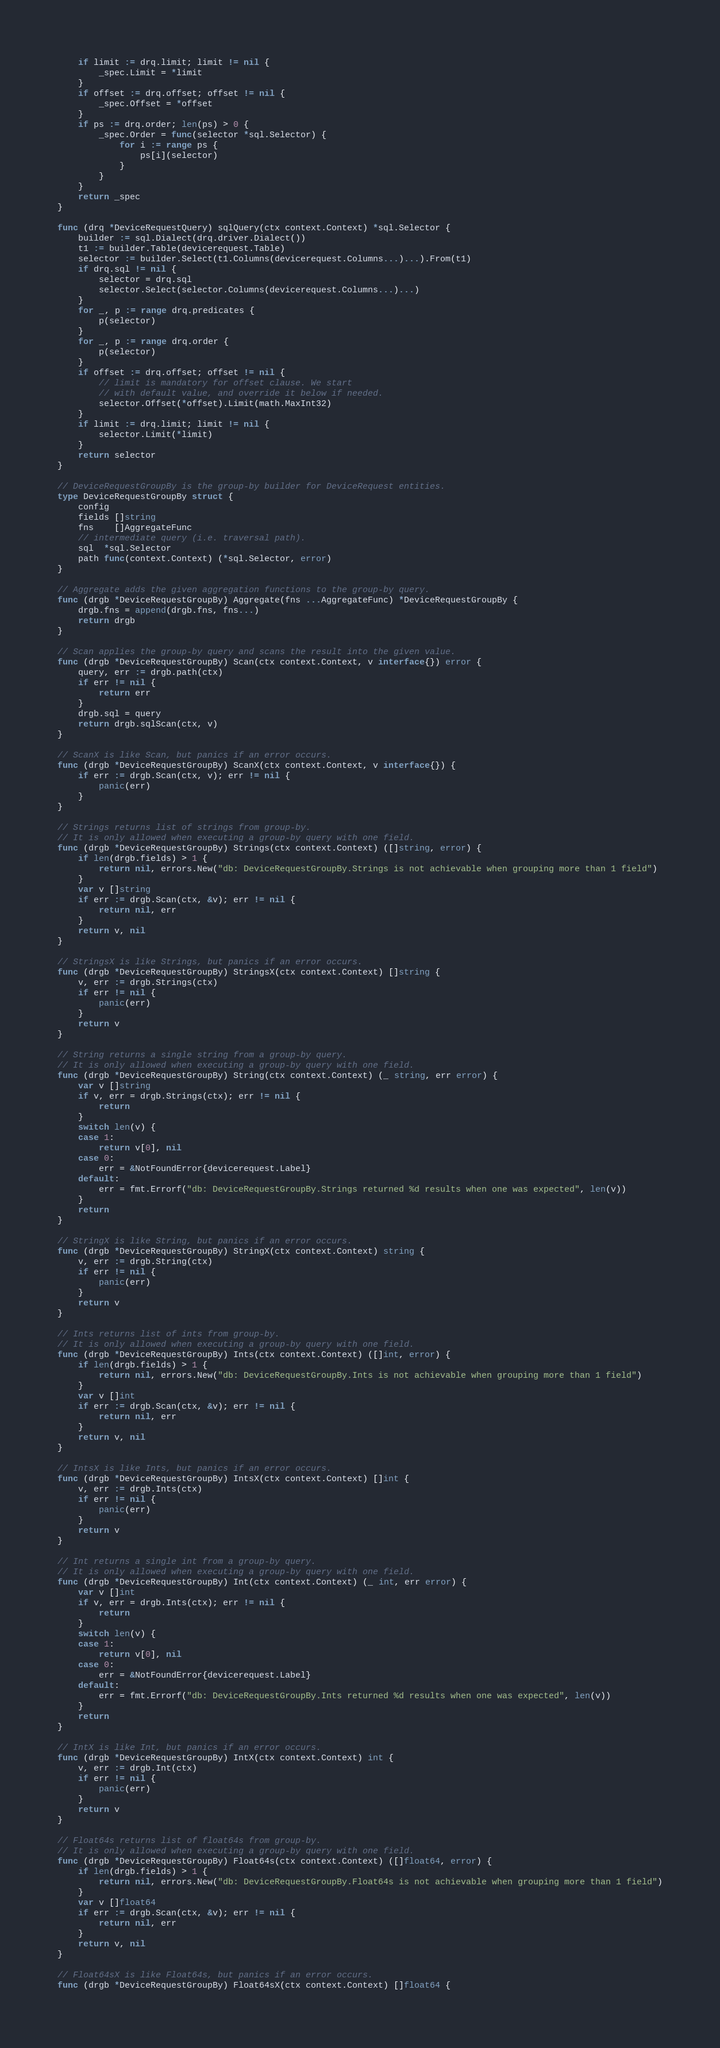Convert code to text. <code><loc_0><loc_0><loc_500><loc_500><_Go_>	if limit := drq.limit; limit != nil {
		_spec.Limit = *limit
	}
	if offset := drq.offset; offset != nil {
		_spec.Offset = *offset
	}
	if ps := drq.order; len(ps) > 0 {
		_spec.Order = func(selector *sql.Selector) {
			for i := range ps {
				ps[i](selector)
			}
		}
	}
	return _spec
}

func (drq *DeviceRequestQuery) sqlQuery(ctx context.Context) *sql.Selector {
	builder := sql.Dialect(drq.driver.Dialect())
	t1 := builder.Table(devicerequest.Table)
	selector := builder.Select(t1.Columns(devicerequest.Columns...)...).From(t1)
	if drq.sql != nil {
		selector = drq.sql
		selector.Select(selector.Columns(devicerequest.Columns...)...)
	}
	for _, p := range drq.predicates {
		p(selector)
	}
	for _, p := range drq.order {
		p(selector)
	}
	if offset := drq.offset; offset != nil {
		// limit is mandatory for offset clause. We start
		// with default value, and override it below if needed.
		selector.Offset(*offset).Limit(math.MaxInt32)
	}
	if limit := drq.limit; limit != nil {
		selector.Limit(*limit)
	}
	return selector
}

// DeviceRequestGroupBy is the group-by builder for DeviceRequest entities.
type DeviceRequestGroupBy struct {
	config
	fields []string
	fns    []AggregateFunc
	// intermediate query (i.e. traversal path).
	sql  *sql.Selector
	path func(context.Context) (*sql.Selector, error)
}

// Aggregate adds the given aggregation functions to the group-by query.
func (drgb *DeviceRequestGroupBy) Aggregate(fns ...AggregateFunc) *DeviceRequestGroupBy {
	drgb.fns = append(drgb.fns, fns...)
	return drgb
}

// Scan applies the group-by query and scans the result into the given value.
func (drgb *DeviceRequestGroupBy) Scan(ctx context.Context, v interface{}) error {
	query, err := drgb.path(ctx)
	if err != nil {
		return err
	}
	drgb.sql = query
	return drgb.sqlScan(ctx, v)
}

// ScanX is like Scan, but panics if an error occurs.
func (drgb *DeviceRequestGroupBy) ScanX(ctx context.Context, v interface{}) {
	if err := drgb.Scan(ctx, v); err != nil {
		panic(err)
	}
}

// Strings returns list of strings from group-by.
// It is only allowed when executing a group-by query with one field.
func (drgb *DeviceRequestGroupBy) Strings(ctx context.Context) ([]string, error) {
	if len(drgb.fields) > 1 {
		return nil, errors.New("db: DeviceRequestGroupBy.Strings is not achievable when grouping more than 1 field")
	}
	var v []string
	if err := drgb.Scan(ctx, &v); err != nil {
		return nil, err
	}
	return v, nil
}

// StringsX is like Strings, but panics if an error occurs.
func (drgb *DeviceRequestGroupBy) StringsX(ctx context.Context) []string {
	v, err := drgb.Strings(ctx)
	if err != nil {
		panic(err)
	}
	return v
}

// String returns a single string from a group-by query.
// It is only allowed when executing a group-by query with one field.
func (drgb *DeviceRequestGroupBy) String(ctx context.Context) (_ string, err error) {
	var v []string
	if v, err = drgb.Strings(ctx); err != nil {
		return
	}
	switch len(v) {
	case 1:
		return v[0], nil
	case 0:
		err = &NotFoundError{devicerequest.Label}
	default:
		err = fmt.Errorf("db: DeviceRequestGroupBy.Strings returned %d results when one was expected", len(v))
	}
	return
}

// StringX is like String, but panics if an error occurs.
func (drgb *DeviceRequestGroupBy) StringX(ctx context.Context) string {
	v, err := drgb.String(ctx)
	if err != nil {
		panic(err)
	}
	return v
}

// Ints returns list of ints from group-by.
// It is only allowed when executing a group-by query with one field.
func (drgb *DeviceRequestGroupBy) Ints(ctx context.Context) ([]int, error) {
	if len(drgb.fields) > 1 {
		return nil, errors.New("db: DeviceRequestGroupBy.Ints is not achievable when grouping more than 1 field")
	}
	var v []int
	if err := drgb.Scan(ctx, &v); err != nil {
		return nil, err
	}
	return v, nil
}

// IntsX is like Ints, but panics if an error occurs.
func (drgb *DeviceRequestGroupBy) IntsX(ctx context.Context) []int {
	v, err := drgb.Ints(ctx)
	if err != nil {
		panic(err)
	}
	return v
}

// Int returns a single int from a group-by query.
// It is only allowed when executing a group-by query with one field.
func (drgb *DeviceRequestGroupBy) Int(ctx context.Context) (_ int, err error) {
	var v []int
	if v, err = drgb.Ints(ctx); err != nil {
		return
	}
	switch len(v) {
	case 1:
		return v[0], nil
	case 0:
		err = &NotFoundError{devicerequest.Label}
	default:
		err = fmt.Errorf("db: DeviceRequestGroupBy.Ints returned %d results when one was expected", len(v))
	}
	return
}

// IntX is like Int, but panics if an error occurs.
func (drgb *DeviceRequestGroupBy) IntX(ctx context.Context) int {
	v, err := drgb.Int(ctx)
	if err != nil {
		panic(err)
	}
	return v
}

// Float64s returns list of float64s from group-by.
// It is only allowed when executing a group-by query with one field.
func (drgb *DeviceRequestGroupBy) Float64s(ctx context.Context) ([]float64, error) {
	if len(drgb.fields) > 1 {
		return nil, errors.New("db: DeviceRequestGroupBy.Float64s is not achievable when grouping more than 1 field")
	}
	var v []float64
	if err := drgb.Scan(ctx, &v); err != nil {
		return nil, err
	}
	return v, nil
}

// Float64sX is like Float64s, but panics if an error occurs.
func (drgb *DeviceRequestGroupBy) Float64sX(ctx context.Context) []float64 {</code> 